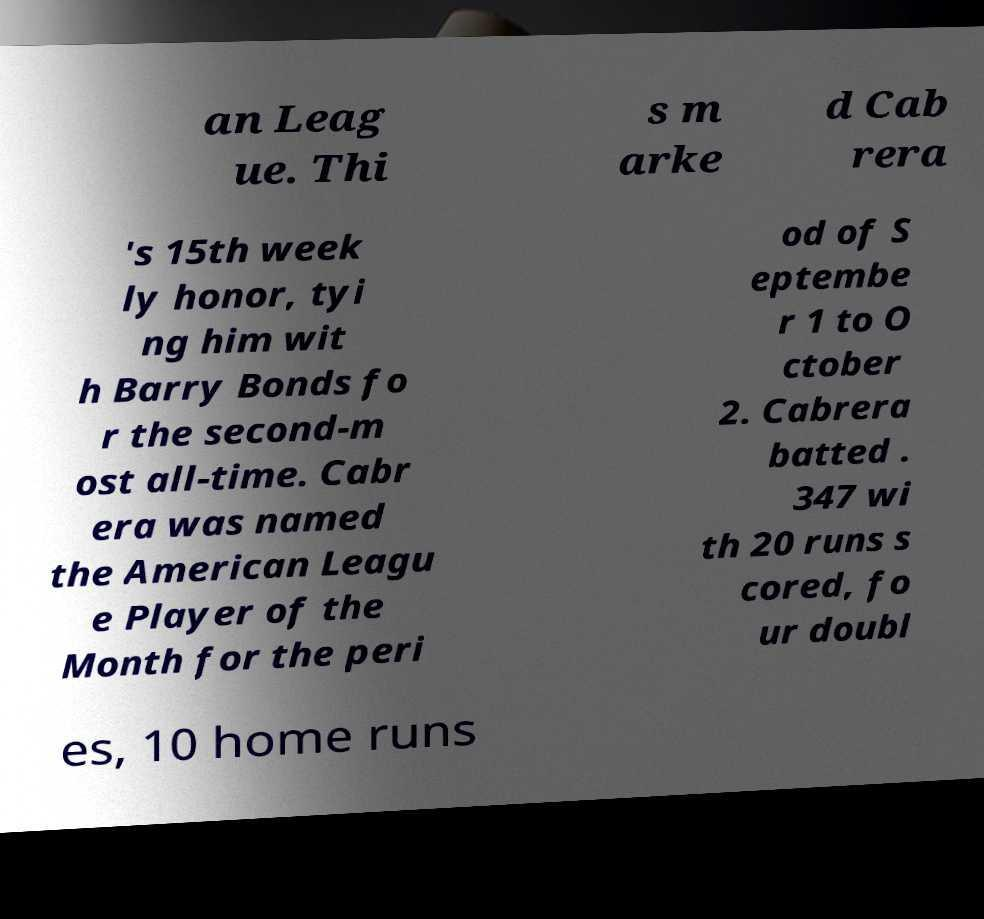I need the written content from this picture converted into text. Can you do that? an Leag ue. Thi s m arke d Cab rera 's 15th week ly honor, tyi ng him wit h Barry Bonds fo r the second-m ost all-time. Cabr era was named the American Leagu e Player of the Month for the peri od of S eptembe r 1 to O ctober 2. Cabrera batted . 347 wi th 20 runs s cored, fo ur doubl es, 10 home runs 